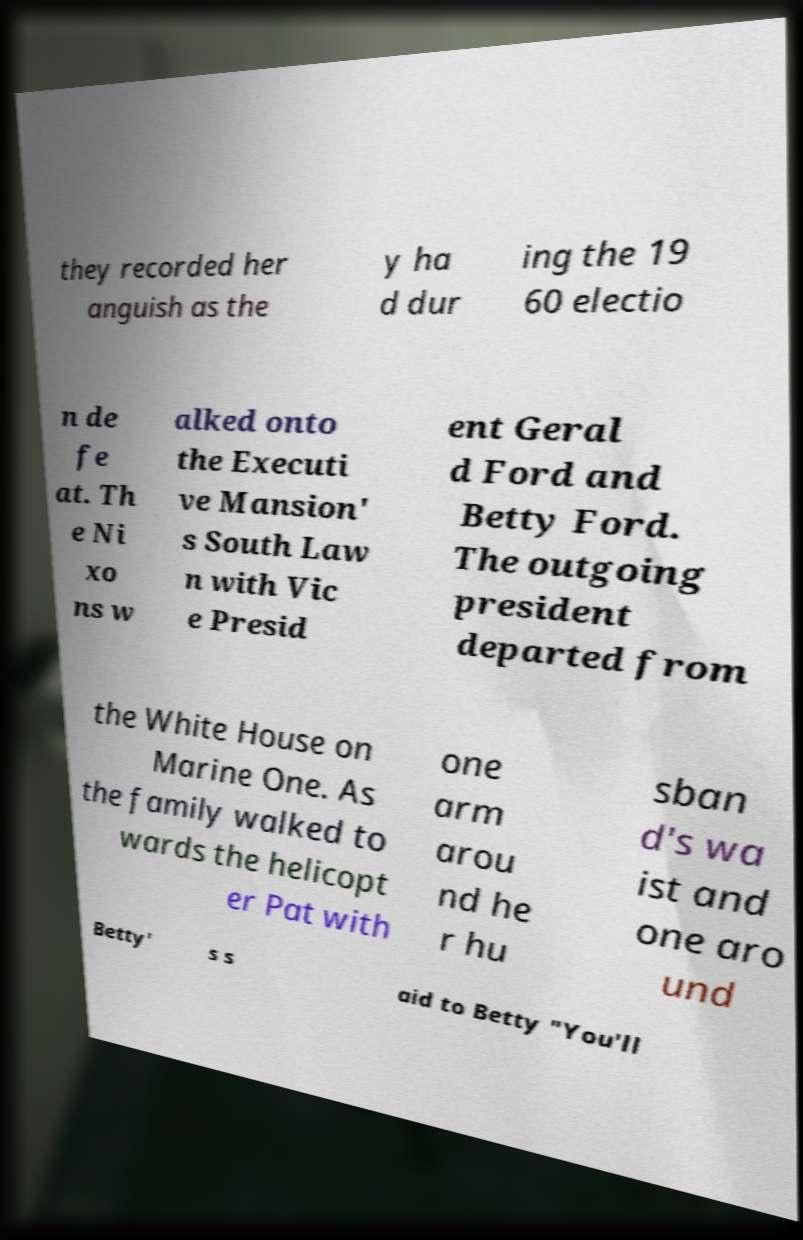What messages or text are displayed in this image? I need them in a readable, typed format. they recorded her anguish as the y ha d dur ing the 19 60 electio n de fe at. Th e Ni xo ns w alked onto the Executi ve Mansion' s South Law n with Vic e Presid ent Geral d Ford and Betty Ford. The outgoing president departed from the White House on Marine One. As the family walked to wards the helicopt er Pat with one arm arou nd he r hu sban d's wa ist and one aro und Betty' s s aid to Betty "You'll 